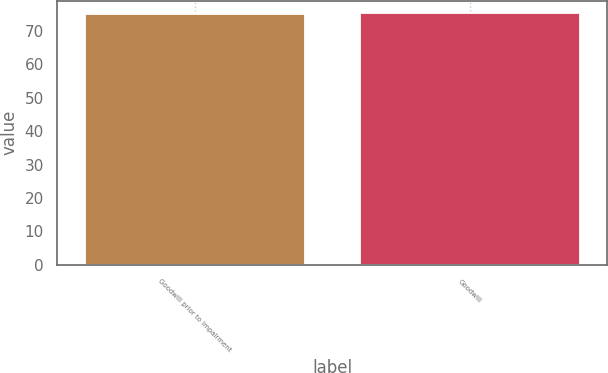Convert chart to OTSL. <chart><loc_0><loc_0><loc_500><loc_500><bar_chart><fcel>Goodwill prior to impairment<fcel>Goodwill<nl><fcel>75.1<fcel>75.2<nl></chart> 